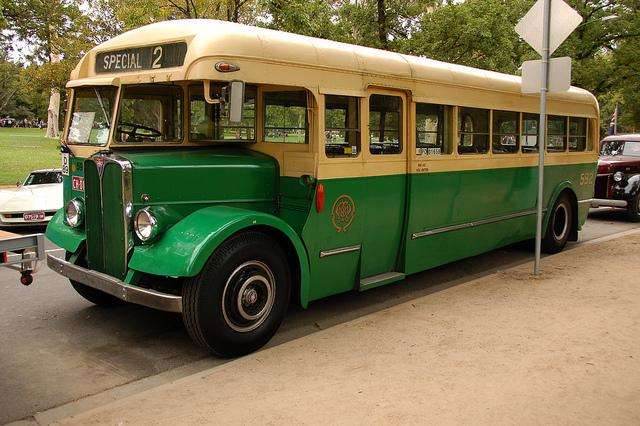Where will the passengers enter?

Choices:
A) rear
B) side
C) top
D) front side 